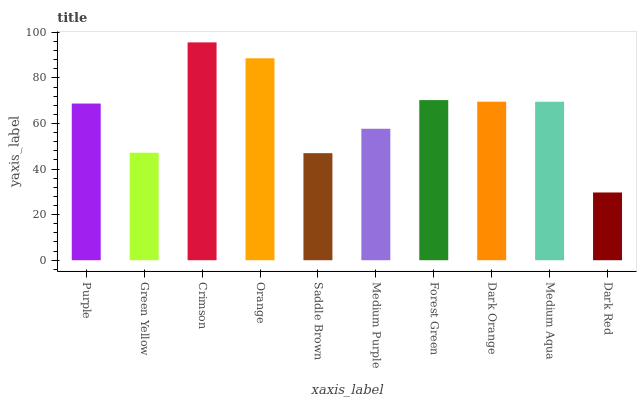Is Dark Red the minimum?
Answer yes or no. Yes. Is Crimson the maximum?
Answer yes or no. Yes. Is Green Yellow the minimum?
Answer yes or no. No. Is Green Yellow the maximum?
Answer yes or no. No. Is Purple greater than Green Yellow?
Answer yes or no. Yes. Is Green Yellow less than Purple?
Answer yes or no. Yes. Is Green Yellow greater than Purple?
Answer yes or no. No. Is Purple less than Green Yellow?
Answer yes or no. No. Is Medium Aqua the high median?
Answer yes or no. Yes. Is Purple the low median?
Answer yes or no. Yes. Is Medium Purple the high median?
Answer yes or no. No. Is Orange the low median?
Answer yes or no. No. 